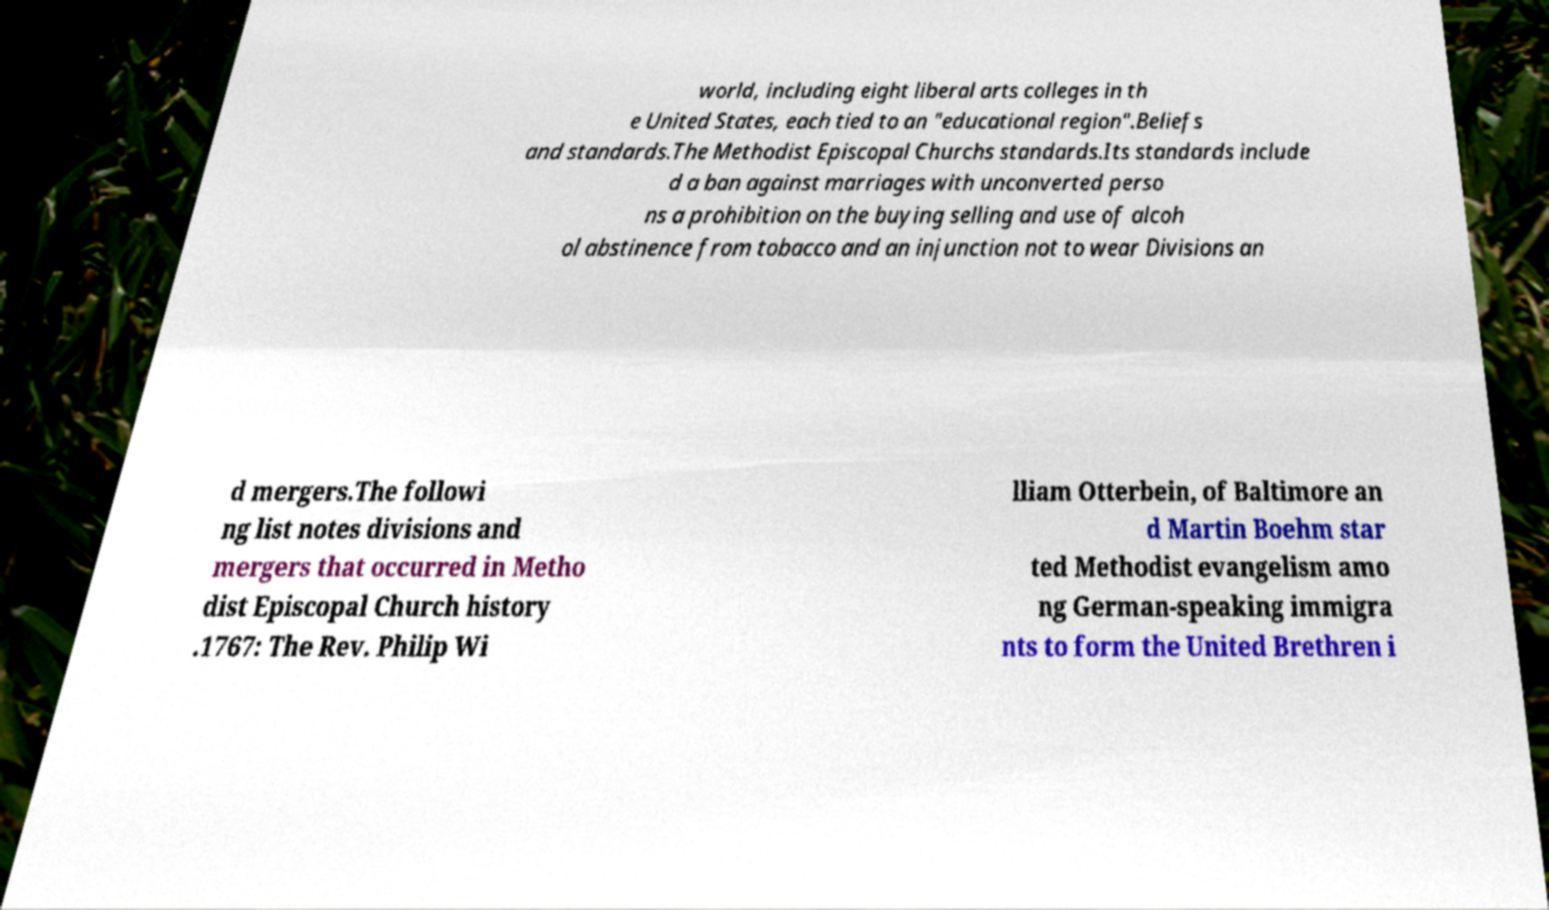Can you read and provide the text displayed in the image?This photo seems to have some interesting text. Can you extract and type it out for me? world, including eight liberal arts colleges in th e United States, each tied to an "educational region".Beliefs and standards.The Methodist Episcopal Churchs standards.Its standards include d a ban against marriages with unconverted perso ns a prohibition on the buying selling and use of alcoh ol abstinence from tobacco and an injunction not to wear Divisions an d mergers.The followi ng list notes divisions and mergers that occurred in Metho dist Episcopal Church history .1767: The Rev. Philip Wi lliam Otterbein, of Baltimore an d Martin Boehm star ted Methodist evangelism amo ng German-speaking immigra nts to form the United Brethren i 